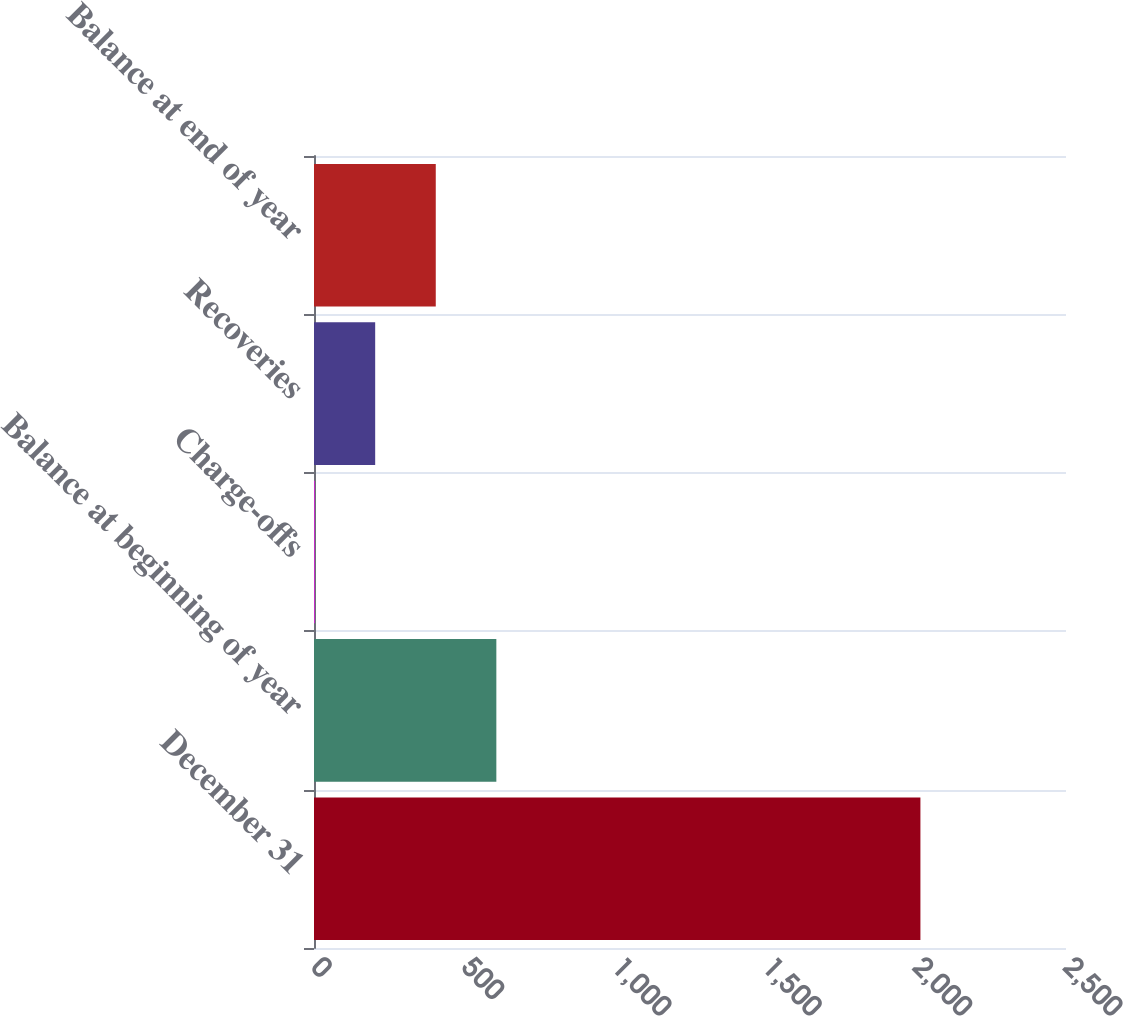Convert chart. <chart><loc_0><loc_0><loc_500><loc_500><bar_chart><fcel>December 31<fcel>Balance at beginning of year<fcel>Charge-offs<fcel>Recoveries<fcel>Balance at end of year<nl><fcel>2016<fcel>606.2<fcel>2<fcel>203.4<fcel>404.8<nl></chart> 